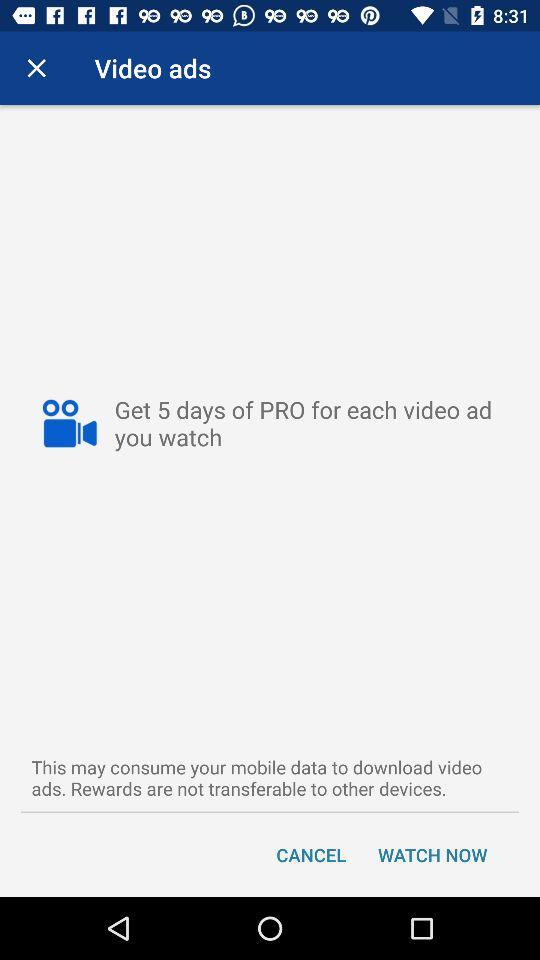How many days of PRO can I get for watching 3 video ads?
Answer the question using a single word or phrase. 15 